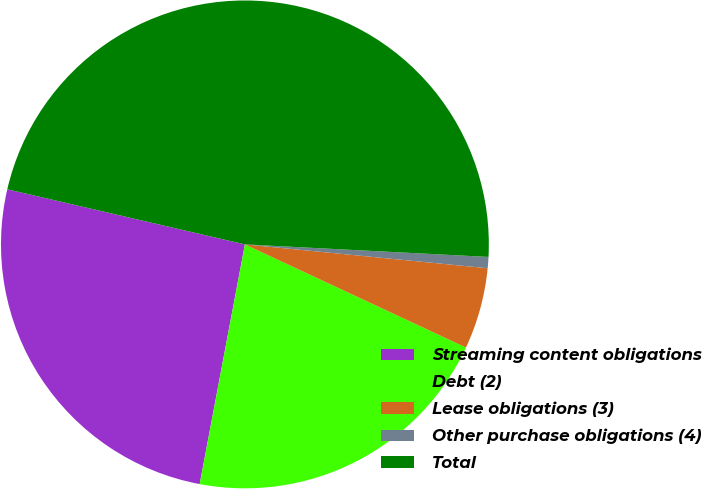<chart> <loc_0><loc_0><loc_500><loc_500><pie_chart><fcel>Streaming content obligations<fcel>Debt (2)<fcel>Lease obligations (3)<fcel>Other purchase obligations (4)<fcel>Total<nl><fcel>25.66%<fcel>21.02%<fcel>5.39%<fcel>0.74%<fcel>47.19%<nl></chart> 